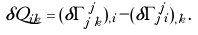<formula> <loc_0><loc_0><loc_500><loc_500>\delta Q _ { i k } = ( \delta \Gamma ^ { \, j } _ { j \, k } ) _ { , i } - ( \delta \Gamma ^ { \, j } _ { j \, i } ) _ { , k } .</formula> 